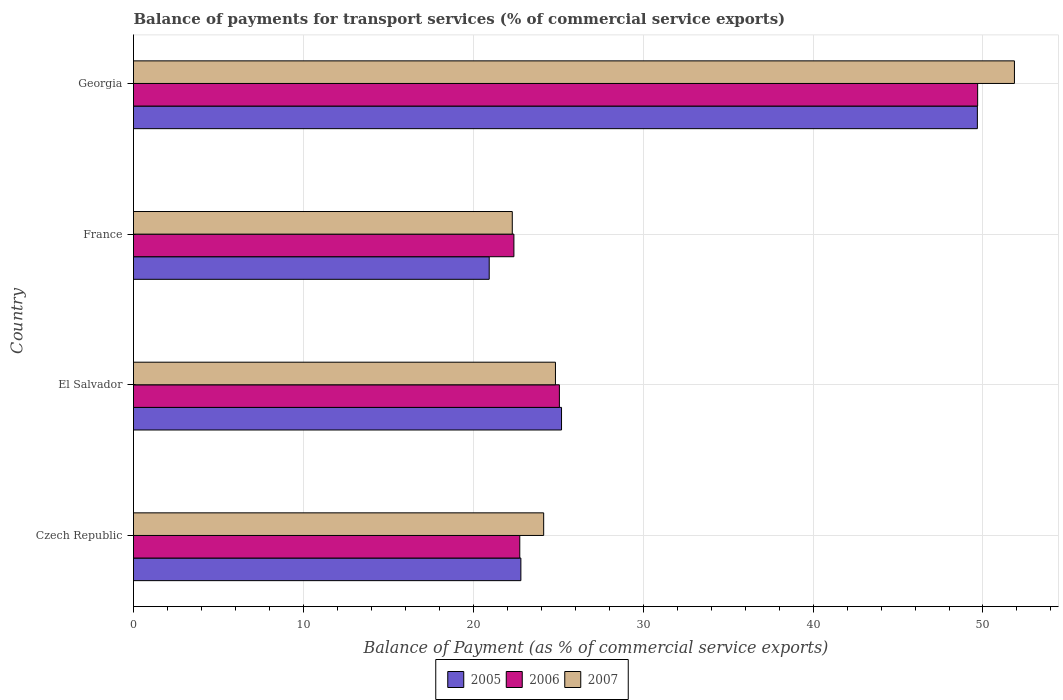Are the number of bars on each tick of the Y-axis equal?
Your answer should be compact. Yes. How many bars are there on the 4th tick from the top?
Ensure brevity in your answer.  3. How many bars are there on the 2nd tick from the bottom?
Offer a very short reply. 3. What is the label of the 1st group of bars from the top?
Your answer should be very brief. Georgia. In how many cases, is the number of bars for a given country not equal to the number of legend labels?
Your response must be concise. 0. What is the balance of payments for transport services in 2005 in Czech Republic?
Provide a succinct answer. 22.8. Across all countries, what is the maximum balance of payments for transport services in 2006?
Keep it short and to the point. 49.69. Across all countries, what is the minimum balance of payments for transport services in 2007?
Ensure brevity in your answer.  22.29. In which country was the balance of payments for transport services in 2005 maximum?
Keep it short and to the point. Georgia. In which country was the balance of payments for transport services in 2006 minimum?
Your answer should be compact. France. What is the total balance of payments for transport services in 2007 in the graph?
Offer a terse response. 123.13. What is the difference between the balance of payments for transport services in 2006 in France and that in Georgia?
Make the answer very short. -27.3. What is the difference between the balance of payments for transport services in 2005 in Czech Republic and the balance of payments for transport services in 2007 in France?
Your response must be concise. 0.51. What is the average balance of payments for transport services in 2005 per country?
Keep it short and to the point. 29.65. What is the difference between the balance of payments for transport services in 2007 and balance of payments for transport services in 2005 in Georgia?
Make the answer very short. 2.18. What is the ratio of the balance of payments for transport services in 2006 in El Salvador to that in France?
Your answer should be compact. 1.12. Is the difference between the balance of payments for transport services in 2007 in Czech Republic and France greater than the difference between the balance of payments for transport services in 2005 in Czech Republic and France?
Provide a succinct answer. No. What is the difference between the highest and the second highest balance of payments for transport services in 2006?
Provide a short and direct response. 24.62. What is the difference between the highest and the lowest balance of payments for transport services in 2007?
Provide a succinct answer. 29.56. In how many countries, is the balance of payments for transport services in 2007 greater than the average balance of payments for transport services in 2007 taken over all countries?
Give a very brief answer. 1. Is the sum of the balance of payments for transport services in 2007 in Czech Republic and El Salvador greater than the maximum balance of payments for transport services in 2005 across all countries?
Offer a terse response. No. What does the 3rd bar from the top in El Salvador represents?
Your answer should be very brief. 2005. What does the 2nd bar from the bottom in France represents?
Provide a short and direct response. 2006. How many countries are there in the graph?
Offer a very short reply. 4. What is the difference between two consecutive major ticks on the X-axis?
Provide a short and direct response. 10. Does the graph contain any zero values?
Provide a short and direct response. No. Does the graph contain grids?
Give a very brief answer. Yes. How many legend labels are there?
Give a very brief answer. 3. What is the title of the graph?
Your answer should be very brief. Balance of payments for transport services (% of commercial service exports). Does "1975" appear as one of the legend labels in the graph?
Offer a terse response. No. What is the label or title of the X-axis?
Provide a short and direct response. Balance of Payment (as % of commercial service exports). What is the Balance of Payment (as % of commercial service exports) in 2005 in Czech Republic?
Keep it short and to the point. 22.8. What is the Balance of Payment (as % of commercial service exports) in 2006 in Czech Republic?
Offer a terse response. 22.74. What is the Balance of Payment (as % of commercial service exports) in 2007 in Czech Republic?
Offer a very short reply. 24.14. What is the Balance of Payment (as % of commercial service exports) in 2005 in El Salvador?
Keep it short and to the point. 25.19. What is the Balance of Payment (as % of commercial service exports) in 2006 in El Salvador?
Offer a terse response. 25.07. What is the Balance of Payment (as % of commercial service exports) in 2007 in El Salvador?
Provide a short and direct response. 24.84. What is the Balance of Payment (as % of commercial service exports) of 2005 in France?
Offer a very short reply. 20.94. What is the Balance of Payment (as % of commercial service exports) of 2006 in France?
Make the answer very short. 22.39. What is the Balance of Payment (as % of commercial service exports) in 2007 in France?
Offer a very short reply. 22.29. What is the Balance of Payment (as % of commercial service exports) of 2005 in Georgia?
Ensure brevity in your answer.  49.67. What is the Balance of Payment (as % of commercial service exports) of 2006 in Georgia?
Offer a very short reply. 49.69. What is the Balance of Payment (as % of commercial service exports) of 2007 in Georgia?
Your response must be concise. 51.85. Across all countries, what is the maximum Balance of Payment (as % of commercial service exports) of 2005?
Offer a terse response. 49.67. Across all countries, what is the maximum Balance of Payment (as % of commercial service exports) of 2006?
Your response must be concise. 49.69. Across all countries, what is the maximum Balance of Payment (as % of commercial service exports) of 2007?
Give a very brief answer. 51.85. Across all countries, what is the minimum Balance of Payment (as % of commercial service exports) of 2005?
Make the answer very short. 20.94. Across all countries, what is the minimum Balance of Payment (as % of commercial service exports) in 2006?
Offer a terse response. 22.39. Across all countries, what is the minimum Balance of Payment (as % of commercial service exports) of 2007?
Keep it short and to the point. 22.29. What is the total Balance of Payment (as % of commercial service exports) in 2005 in the graph?
Your response must be concise. 118.6. What is the total Balance of Payment (as % of commercial service exports) in 2006 in the graph?
Keep it short and to the point. 119.88. What is the total Balance of Payment (as % of commercial service exports) of 2007 in the graph?
Your answer should be very brief. 123.13. What is the difference between the Balance of Payment (as % of commercial service exports) in 2005 in Czech Republic and that in El Salvador?
Offer a very short reply. -2.39. What is the difference between the Balance of Payment (as % of commercial service exports) of 2006 in Czech Republic and that in El Salvador?
Keep it short and to the point. -2.33. What is the difference between the Balance of Payment (as % of commercial service exports) in 2007 in Czech Republic and that in El Salvador?
Offer a very short reply. -0.69. What is the difference between the Balance of Payment (as % of commercial service exports) in 2005 in Czech Republic and that in France?
Offer a terse response. 1.86. What is the difference between the Balance of Payment (as % of commercial service exports) of 2006 in Czech Republic and that in France?
Provide a succinct answer. 0.35. What is the difference between the Balance of Payment (as % of commercial service exports) in 2007 in Czech Republic and that in France?
Give a very brief answer. 1.85. What is the difference between the Balance of Payment (as % of commercial service exports) in 2005 in Czech Republic and that in Georgia?
Your answer should be very brief. -26.87. What is the difference between the Balance of Payment (as % of commercial service exports) in 2006 in Czech Republic and that in Georgia?
Your response must be concise. -26.95. What is the difference between the Balance of Payment (as % of commercial service exports) in 2007 in Czech Republic and that in Georgia?
Provide a short and direct response. -27.71. What is the difference between the Balance of Payment (as % of commercial service exports) of 2005 in El Salvador and that in France?
Offer a terse response. 4.26. What is the difference between the Balance of Payment (as % of commercial service exports) in 2006 in El Salvador and that in France?
Ensure brevity in your answer.  2.68. What is the difference between the Balance of Payment (as % of commercial service exports) of 2007 in El Salvador and that in France?
Provide a short and direct response. 2.54. What is the difference between the Balance of Payment (as % of commercial service exports) in 2005 in El Salvador and that in Georgia?
Give a very brief answer. -24.48. What is the difference between the Balance of Payment (as % of commercial service exports) in 2006 in El Salvador and that in Georgia?
Offer a very short reply. -24.62. What is the difference between the Balance of Payment (as % of commercial service exports) in 2007 in El Salvador and that in Georgia?
Give a very brief answer. -27.02. What is the difference between the Balance of Payment (as % of commercial service exports) in 2005 in France and that in Georgia?
Provide a succinct answer. -28.73. What is the difference between the Balance of Payment (as % of commercial service exports) of 2006 in France and that in Georgia?
Offer a terse response. -27.3. What is the difference between the Balance of Payment (as % of commercial service exports) in 2007 in France and that in Georgia?
Make the answer very short. -29.56. What is the difference between the Balance of Payment (as % of commercial service exports) of 2005 in Czech Republic and the Balance of Payment (as % of commercial service exports) of 2006 in El Salvador?
Your answer should be very brief. -2.27. What is the difference between the Balance of Payment (as % of commercial service exports) of 2005 in Czech Republic and the Balance of Payment (as % of commercial service exports) of 2007 in El Salvador?
Your answer should be very brief. -2.04. What is the difference between the Balance of Payment (as % of commercial service exports) in 2006 in Czech Republic and the Balance of Payment (as % of commercial service exports) in 2007 in El Salvador?
Provide a succinct answer. -2.1. What is the difference between the Balance of Payment (as % of commercial service exports) of 2005 in Czech Republic and the Balance of Payment (as % of commercial service exports) of 2006 in France?
Your answer should be compact. 0.41. What is the difference between the Balance of Payment (as % of commercial service exports) in 2005 in Czech Republic and the Balance of Payment (as % of commercial service exports) in 2007 in France?
Provide a short and direct response. 0.51. What is the difference between the Balance of Payment (as % of commercial service exports) of 2006 in Czech Republic and the Balance of Payment (as % of commercial service exports) of 2007 in France?
Give a very brief answer. 0.44. What is the difference between the Balance of Payment (as % of commercial service exports) of 2005 in Czech Republic and the Balance of Payment (as % of commercial service exports) of 2006 in Georgia?
Keep it short and to the point. -26.89. What is the difference between the Balance of Payment (as % of commercial service exports) in 2005 in Czech Republic and the Balance of Payment (as % of commercial service exports) in 2007 in Georgia?
Keep it short and to the point. -29.05. What is the difference between the Balance of Payment (as % of commercial service exports) of 2006 in Czech Republic and the Balance of Payment (as % of commercial service exports) of 2007 in Georgia?
Offer a very short reply. -29.12. What is the difference between the Balance of Payment (as % of commercial service exports) of 2005 in El Salvador and the Balance of Payment (as % of commercial service exports) of 2006 in France?
Keep it short and to the point. 2.8. What is the difference between the Balance of Payment (as % of commercial service exports) in 2005 in El Salvador and the Balance of Payment (as % of commercial service exports) in 2007 in France?
Ensure brevity in your answer.  2.9. What is the difference between the Balance of Payment (as % of commercial service exports) of 2006 in El Salvador and the Balance of Payment (as % of commercial service exports) of 2007 in France?
Make the answer very short. 2.77. What is the difference between the Balance of Payment (as % of commercial service exports) in 2005 in El Salvador and the Balance of Payment (as % of commercial service exports) in 2006 in Georgia?
Give a very brief answer. -24.49. What is the difference between the Balance of Payment (as % of commercial service exports) of 2005 in El Salvador and the Balance of Payment (as % of commercial service exports) of 2007 in Georgia?
Offer a very short reply. -26.66. What is the difference between the Balance of Payment (as % of commercial service exports) of 2006 in El Salvador and the Balance of Payment (as % of commercial service exports) of 2007 in Georgia?
Offer a terse response. -26.78. What is the difference between the Balance of Payment (as % of commercial service exports) in 2005 in France and the Balance of Payment (as % of commercial service exports) in 2006 in Georgia?
Provide a short and direct response. -28.75. What is the difference between the Balance of Payment (as % of commercial service exports) of 2005 in France and the Balance of Payment (as % of commercial service exports) of 2007 in Georgia?
Your answer should be very brief. -30.91. What is the difference between the Balance of Payment (as % of commercial service exports) of 2006 in France and the Balance of Payment (as % of commercial service exports) of 2007 in Georgia?
Keep it short and to the point. -29.46. What is the average Balance of Payment (as % of commercial service exports) of 2005 per country?
Provide a succinct answer. 29.65. What is the average Balance of Payment (as % of commercial service exports) of 2006 per country?
Your answer should be very brief. 29.97. What is the average Balance of Payment (as % of commercial service exports) in 2007 per country?
Keep it short and to the point. 30.78. What is the difference between the Balance of Payment (as % of commercial service exports) in 2005 and Balance of Payment (as % of commercial service exports) in 2006 in Czech Republic?
Your response must be concise. 0.06. What is the difference between the Balance of Payment (as % of commercial service exports) in 2005 and Balance of Payment (as % of commercial service exports) in 2007 in Czech Republic?
Keep it short and to the point. -1.34. What is the difference between the Balance of Payment (as % of commercial service exports) in 2006 and Balance of Payment (as % of commercial service exports) in 2007 in Czech Republic?
Ensure brevity in your answer.  -1.41. What is the difference between the Balance of Payment (as % of commercial service exports) of 2005 and Balance of Payment (as % of commercial service exports) of 2006 in El Salvador?
Your answer should be compact. 0.13. What is the difference between the Balance of Payment (as % of commercial service exports) of 2005 and Balance of Payment (as % of commercial service exports) of 2007 in El Salvador?
Your answer should be compact. 0.36. What is the difference between the Balance of Payment (as % of commercial service exports) of 2006 and Balance of Payment (as % of commercial service exports) of 2007 in El Salvador?
Provide a succinct answer. 0.23. What is the difference between the Balance of Payment (as % of commercial service exports) of 2005 and Balance of Payment (as % of commercial service exports) of 2006 in France?
Your answer should be very brief. -1.45. What is the difference between the Balance of Payment (as % of commercial service exports) in 2005 and Balance of Payment (as % of commercial service exports) in 2007 in France?
Ensure brevity in your answer.  -1.36. What is the difference between the Balance of Payment (as % of commercial service exports) in 2006 and Balance of Payment (as % of commercial service exports) in 2007 in France?
Keep it short and to the point. 0.1. What is the difference between the Balance of Payment (as % of commercial service exports) of 2005 and Balance of Payment (as % of commercial service exports) of 2006 in Georgia?
Keep it short and to the point. -0.02. What is the difference between the Balance of Payment (as % of commercial service exports) in 2005 and Balance of Payment (as % of commercial service exports) in 2007 in Georgia?
Your response must be concise. -2.18. What is the difference between the Balance of Payment (as % of commercial service exports) in 2006 and Balance of Payment (as % of commercial service exports) in 2007 in Georgia?
Make the answer very short. -2.17. What is the ratio of the Balance of Payment (as % of commercial service exports) in 2005 in Czech Republic to that in El Salvador?
Your answer should be very brief. 0.91. What is the ratio of the Balance of Payment (as % of commercial service exports) in 2006 in Czech Republic to that in El Salvador?
Your response must be concise. 0.91. What is the ratio of the Balance of Payment (as % of commercial service exports) in 2007 in Czech Republic to that in El Salvador?
Your answer should be compact. 0.97. What is the ratio of the Balance of Payment (as % of commercial service exports) of 2005 in Czech Republic to that in France?
Offer a very short reply. 1.09. What is the ratio of the Balance of Payment (as % of commercial service exports) in 2006 in Czech Republic to that in France?
Ensure brevity in your answer.  1.02. What is the ratio of the Balance of Payment (as % of commercial service exports) of 2007 in Czech Republic to that in France?
Offer a very short reply. 1.08. What is the ratio of the Balance of Payment (as % of commercial service exports) in 2005 in Czech Republic to that in Georgia?
Your response must be concise. 0.46. What is the ratio of the Balance of Payment (as % of commercial service exports) in 2006 in Czech Republic to that in Georgia?
Your answer should be compact. 0.46. What is the ratio of the Balance of Payment (as % of commercial service exports) of 2007 in Czech Republic to that in Georgia?
Provide a succinct answer. 0.47. What is the ratio of the Balance of Payment (as % of commercial service exports) in 2005 in El Salvador to that in France?
Your response must be concise. 1.2. What is the ratio of the Balance of Payment (as % of commercial service exports) of 2006 in El Salvador to that in France?
Make the answer very short. 1.12. What is the ratio of the Balance of Payment (as % of commercial service exports) of 2007 in El Salvador to that in France?
Make the answer very short. 1.11. What is the ratio of the Balance of Payment (as % of commercial service exports) of 2005 in El Salvador to that in Georgia?
Your response must be concise. 0.51. What is the ratio of the Balance of Payment (as % of commercial service exports) in 2006 in El Salvador to that in Georgia?
Offer a very short reply. 0.5. What is the ratio of the Balance of Payment (as % of commercial service exports) in 2007 in El Salvador to that in Georgia?
Make the answer very short. 0.48. What is the ratio of the Balance of Payment (as % of commercial service exports) in 2005 in France to that in Georgia?
Give a very brief answer. 0.42. What is the ratio of the Balance of Payment (as % of commercial service exports) of 2006 in France to that in Georgia?
Your answer should be very brief. 0.45. What is the ratio of the Balance of Payment (as % of commercial service exports) in 2007 in France to that in Georgia?
Give a very brief answer. 0.43. What is the difference between the highest and the second highest Balance of Payment (as % of commercial service exports) of 2005?
Provide a short and direct response. 24.48. What is the difference between the highest and the second highest Balance of Payment (as % of commercial service exports) of 2006?
Ensure brevity in your answer.  24.62. What is the difference between the highest and the second highest Balance of Payment (as % of commercial service exports) of 2007?
Your answer should be compact. 27.02. What is the difference between the highest and the lowest Balance of Payment (as % of commercial service exports) in 2005?
Provide a short and direct response. 28.73. What is the difference between the highest and the lowest Balance of Payment (as % of commercial service exports) in 2006?
Your response must be concise. 27.3. What is the difference between the highest and the lowest Balance of Payment (as % of commercial service exports) of 2007?
Your response must be concise. 29.56. 